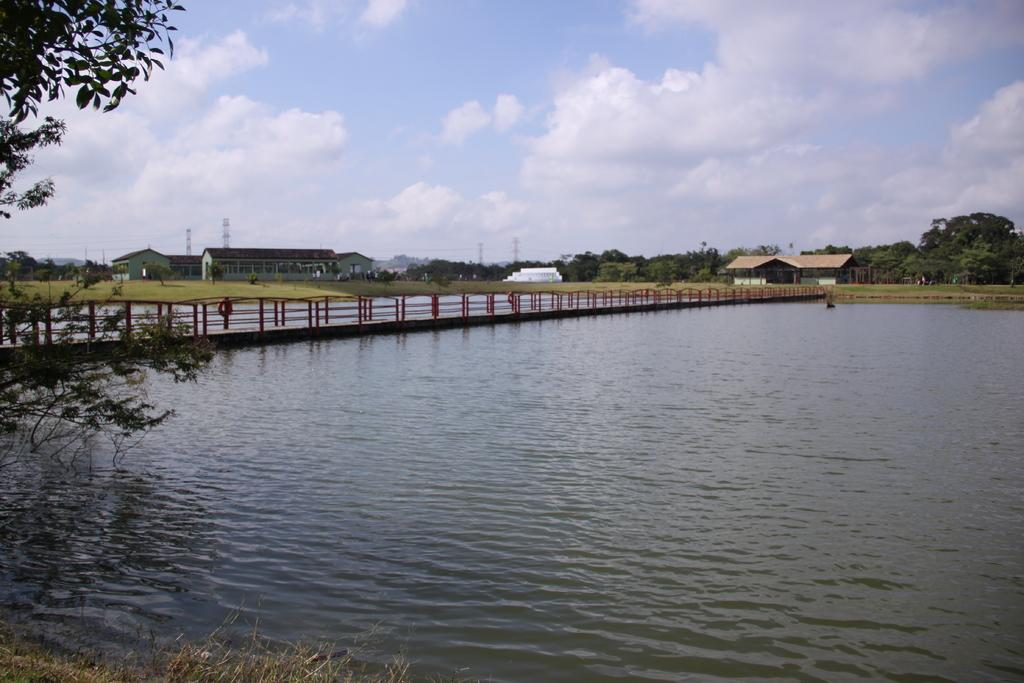What is the main element in the image? There is water in the image. What type of structure can be seen crossing the water? There is a bridge with rod fencing in the image. What type of vegetation is visible at the bottom of the image? Grass is visible at the bottom of the image. What other natural elements can be seen in the image? There are trees in the image. What type of buildings are present in the image? There are houses and towers in the image. What is the condition of the sky in the image? The sky is cloudy at the top of the image. What type of pencil is being used to draw the houses in the image? There is no pencil present in the image, as it is a photograph or illustration of the scene. 